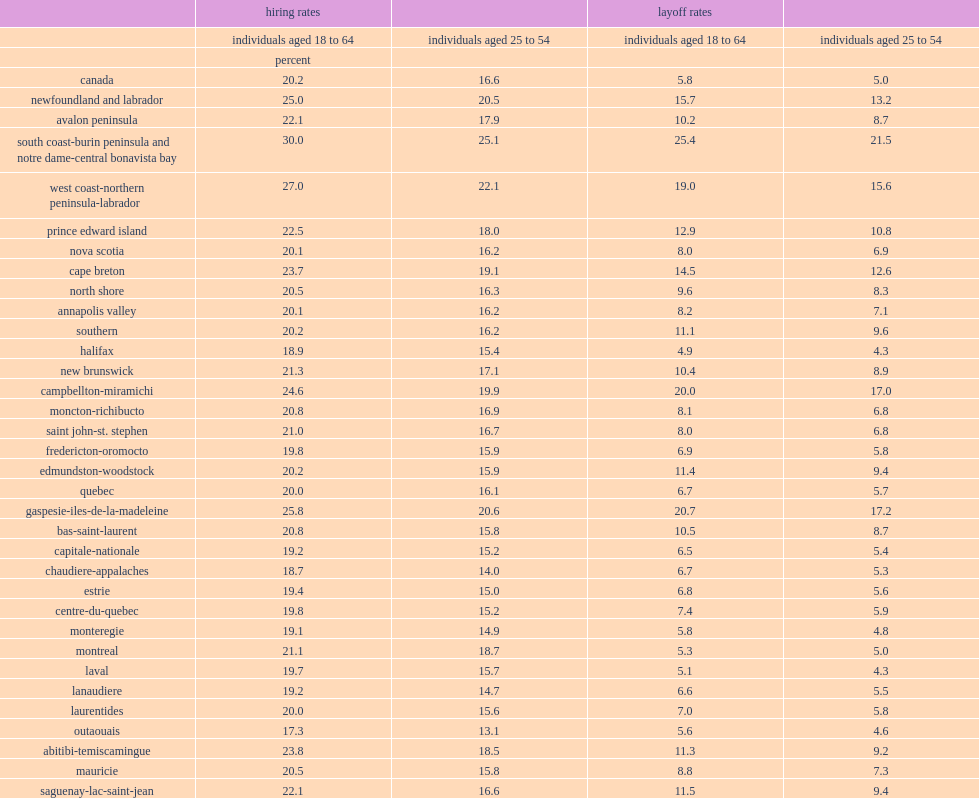From 2003 to 2013, what percent of employees aged 18 to 64 were laid-off in canada? 5.8. From 2003 to 2013, what is the canada's hiring rate for employees aged 18 to 64? 20.2. What is the layoff rates for employees aged 18 to 64 in newfoundland and labrador? 15.7. 